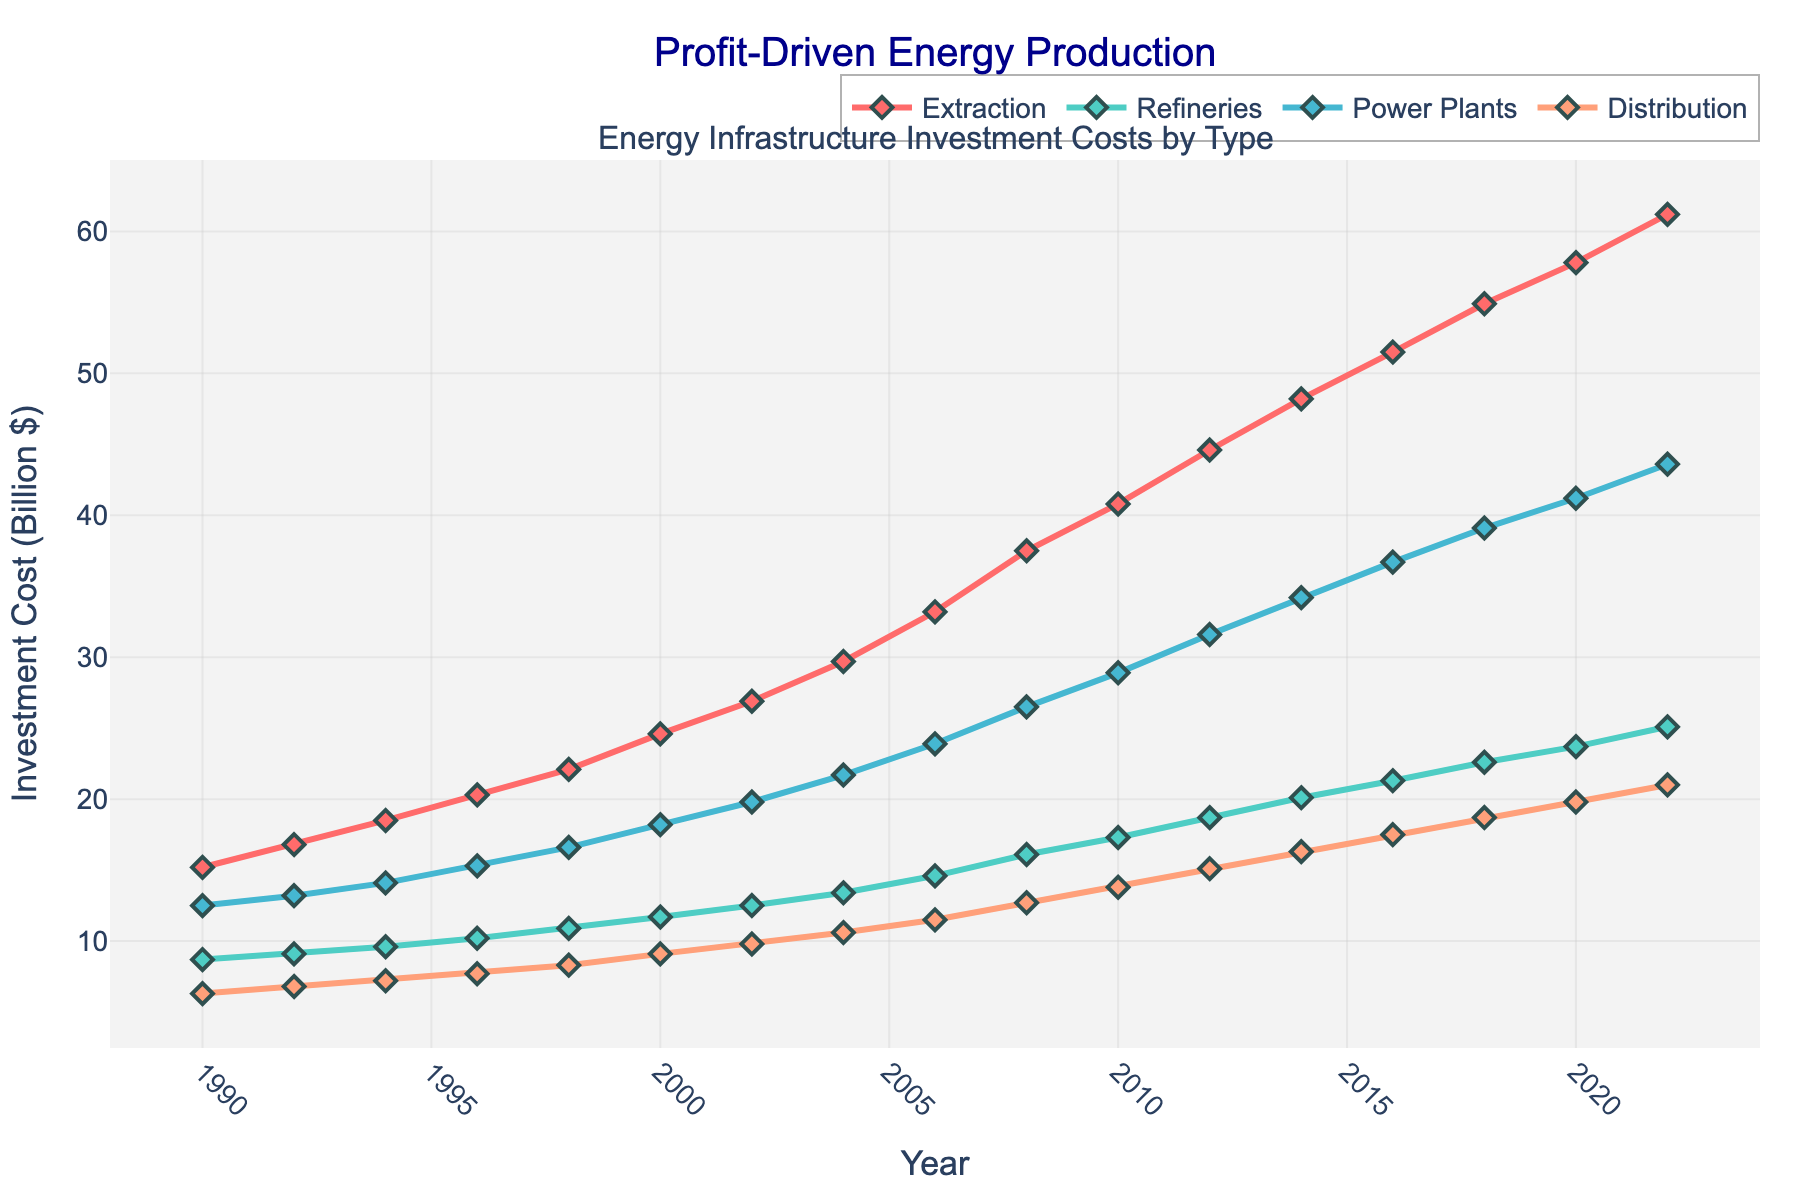What has been the general trend in investment costs for extraction from 1990 to 2022? Observing the line graph, the investment costs for extraction have shown a continuous upward trend from 1990 to 2022.
Answer: Upward trend Which year saw the highest investment in power plants, and what was the investment amount? The line representing power plant investments reaches its peak in 2022 at an investment amount of 43.6 billion dollars.
Answer: 2022, 43.6 billion dollars How did investments in refineries in 2010 compare to those in 1992? The line chart indicates that refinery investments in 2010 were significantly higher than in 1992. In 1992, the investment was 9.1 billion dollars, while in 2010 it was 17.3 billion dollars.
Answer: Higher in 2010 What is the combined total investment in distribution for the years 2000 and 2020? Sum the distribution investments for 2000 (9.1 billion dollars) and 2020 (19.8 billion dollars) to get the total: 9.1 + 19.8 = 28.9 billion dollars.
Answer: 28.9 billion dollars Has the increase in investment costs for extraction been more significant than for refineries from 1990 to 2022? By comparing the slopes of the lines, extraction investment costs increased from 15.2 to 61.2 billion dollars (change of 46 billion), while refinery costs increased from 8.7 to 25.1 billion dollars (change of 16.4 billion). Hence, the increase has been more significant for extraction.
Answer: Yes What is the average investment in power plants over all the years shown? Sum the investment amounts for power plants over the years and divide by the number of data points. (12.5 + 13.2 + 14.1 + 15.3 + 16.6 + 18.2 + 19.8 + 21.7 + 23.9 + 26.5 + 28.9 + 31.6 + 34.2 + 36.7 + 39.1 + 41.2 + 43.6) / 17 = 26.15 billion dollars.
Answer: 26.15 billion dollars Which investment type had the least amount of fluctuation in costs over the period? By visual inspection, the line for distribution shows the least steepness and the smallest incremental changes, indicating the least fluctuation.
Answer: Distribution What color represents investments in refineries on the chart? The line for refinery investments is colored in green.
Answer: Green Between which consecutive periods did the investment in extraction see the largest single increase? The largest single increase for extraction investments occurred between 2006 (33.2 billion dollars) and 2008 (37.5 billion dollars), an increase of 4.3 billion dollars.
Answer: 2006-2008 Are there any years where investments in all types simultaneously decreased or remained the same? Observing the line chart for all investment types, there are no years where all investments decreased or remained constant simultaneously. All types show a generally rising trend.
Answer: No 